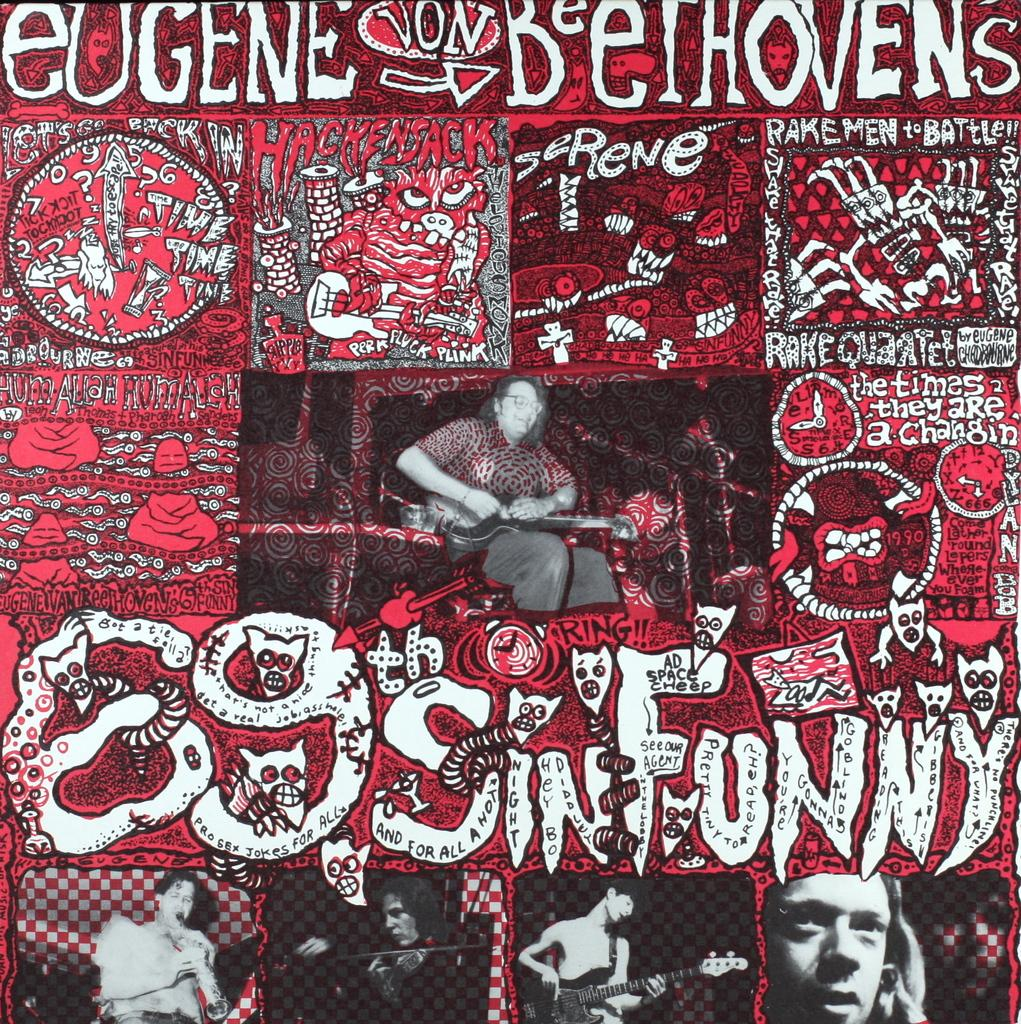What is featured in the image? There is a poster in the image. What colors are used in the poster? The poster is in red and white color. What else can be seen in the image besides the poster? There are people playing musical instruments in the image. How many hats are visible on the people playing musical instruments in the image? There is no mention of hats in the image, so it is impossible to determine the number of hats visible. 